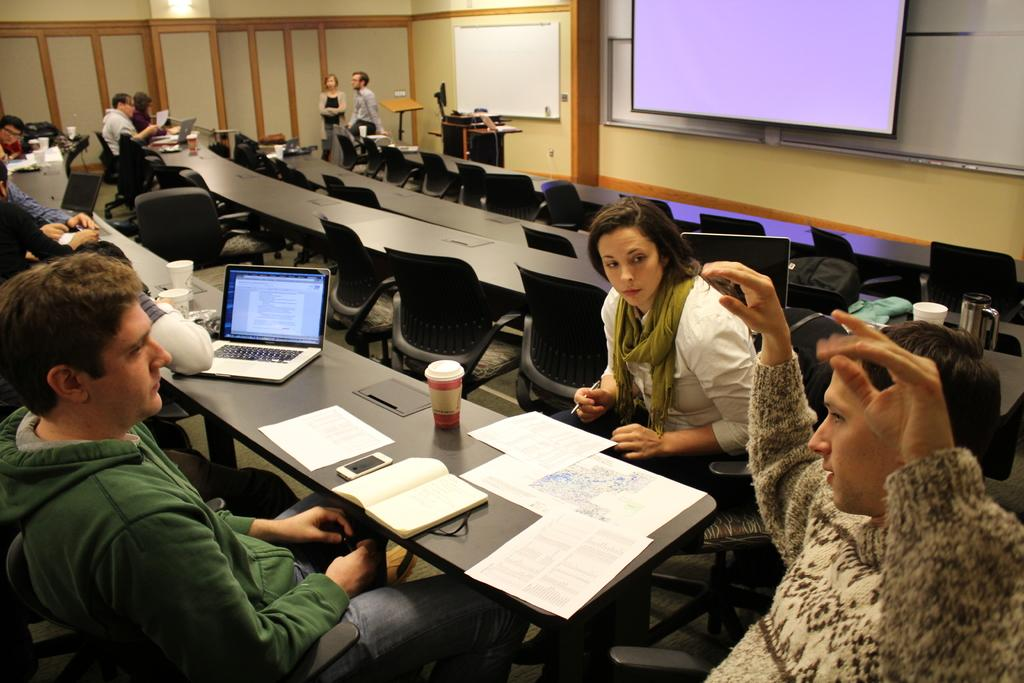What are the persons in the image doing? The persons in the image are sitting on chairs. What objects can be seen on the table in the image? There are books and a laptop on the table in the image. What is the purpose of the projector screen in the image? The projector screen is likely used for presentations or displaying visuals. Can you see any clams on the table in the image? No, there are no clams present in the image. How does the ant show respect to the persons sitting on chairs in the image? There are no ants present in the image, so it is not possible to determine how an ant might show respect. 